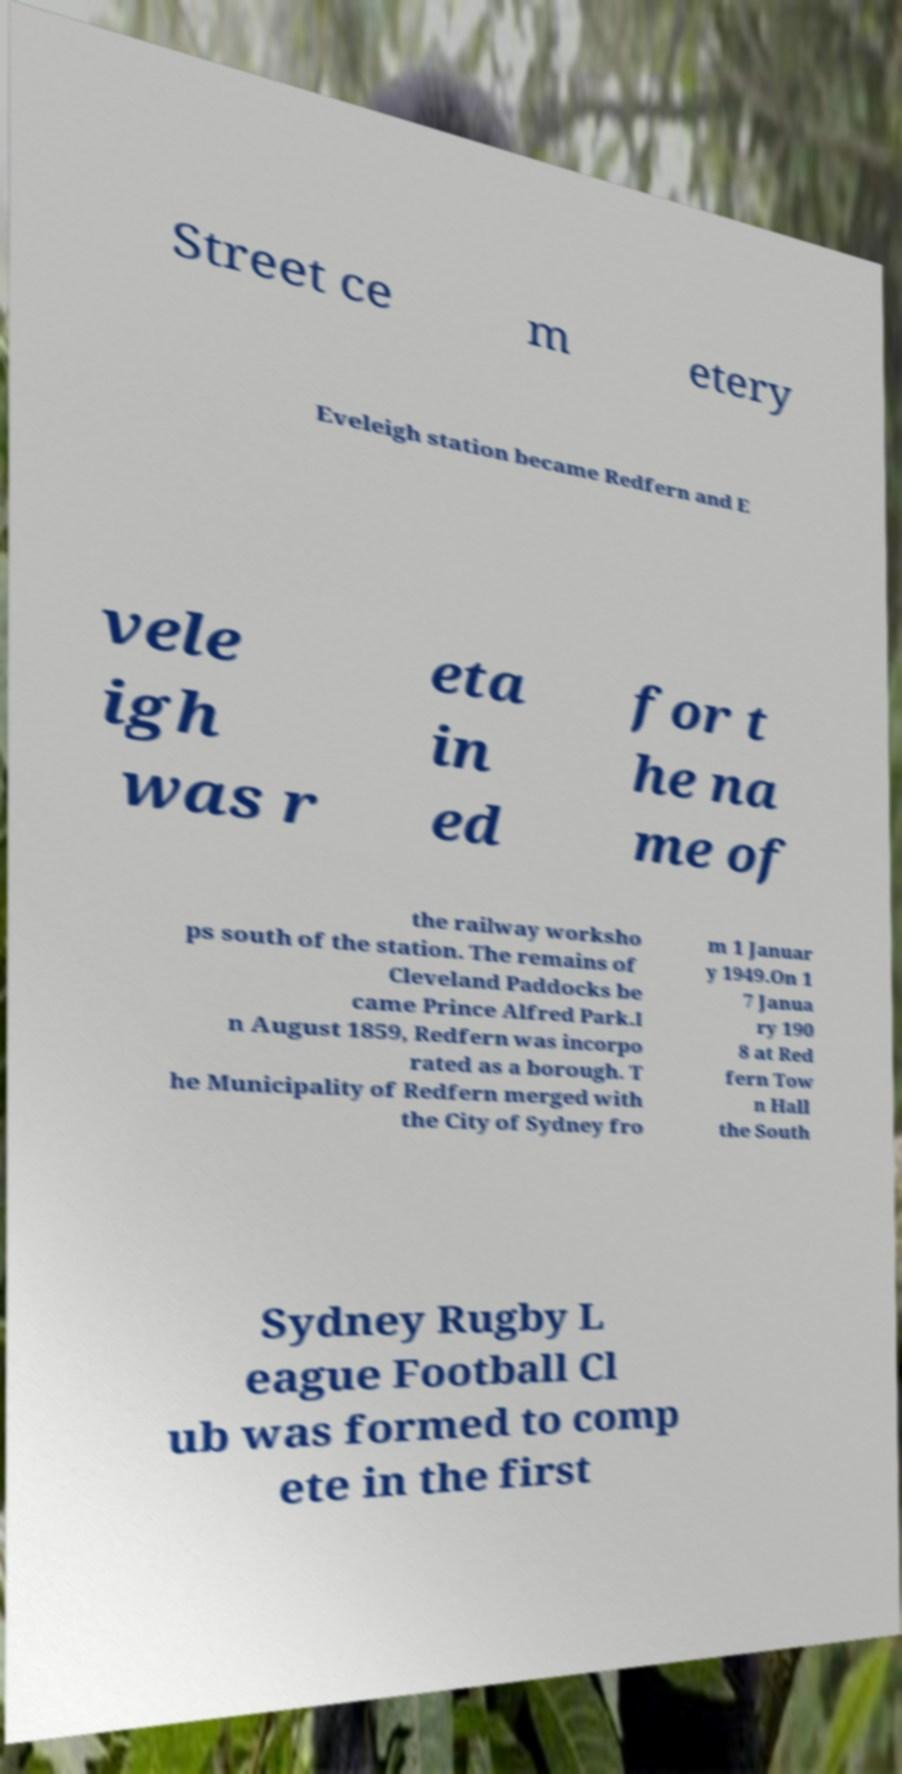Could you assist in decoding the text presented in this image and type it out clearly? Street ce m etery Eveleigh station became Redfern and E vele igh was r eta in ed for t he na me of the railway worksho ps south of the station. The remains of Cleveland Paddocks be came Prince Alfred Park.I n August 1859, Redfern was incorpo rated as a borough. T he Municipality of Redfern merged with the City of Sydney fro m 1 Januar y 1949.On 1 7 Janua ry 190 8 at Red fern Tow n Hall the South Sydney Rugby L eague Football Cl ub was formed to comp ete in the first 